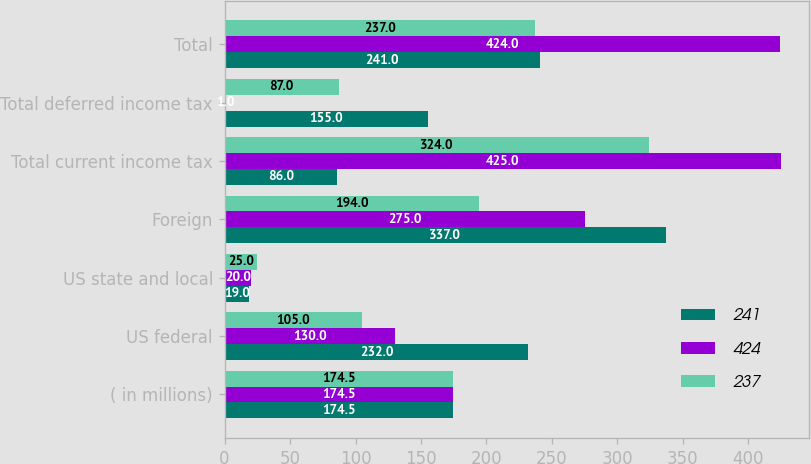<chart> <loc_0><loc_0><loc_500><loc_500><stacked_bar_chart><ecel><fcel>( in millions)<fcel>US federal<fcel>US state and local<fcel>Foreign<fcel>Total current income tax<fcel>Total deferred income tax<fcel>Total<nl><fcel>241<fcel>174.5<fcel>232<fcel>19<fcel>337<fcel>86<fcel>155<fcel>241<nl><fcel>424<fcel>174.5<fcel>130<fcel>20<fcel>275<fcel>425<fcel>1<fcel>424<nl><fcel>237<fcel>174.5<fcel>105<fcel>25<fcel>194<fcel>324<fcel>87<fcel>237<nl></chart> 